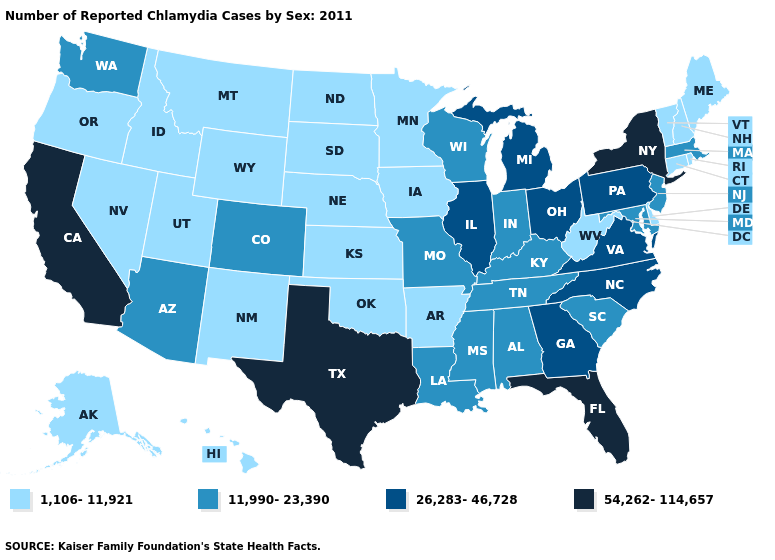Is the legend a continuous bar?
Quick response, please. No. Name the states that have a value in the range 11,990-23,390?
Write a very short answer. Alabama, Arizona, Colorado, Indiana, Kentucky, Louisiana, Maryland, Massachusetts, Mississippi, Missouri, New Jersey, South Carolina, Tennessee, Washington, Wisconsin. What is the value of Washington?
Write a very short answer. 11,990-23,390. Which states hav the highest value in the MidWest?
Give a very brief answer. Illinois, Michigan, Ohio. Name the states that have a value in the range 54,262-114,657?
Give a very brief answer. California, Florida, New York, Texas. Does Missouri have the highest value in the USA?
Short answer required. No. Name the states that have a value in the range 1,106-11,921?
Keep it brief. Alaska, Arkansas, Connecticut, Delaware, Hawaii, Idaho, Iowa, Kansas, Maine, Minnesota, Montana, Nebraska, Nevada, New Hampshire, New Mexico, North Dakota, Oklahoma, Oregon, Rhode Island, South Dakota, Utah, Vermont, West Virginia, Wyoming. Is the legend a continuous bar?
Quick response, please. No. Among the states that border Idaho , does Washington have the lowest value?
Write a very short answer. No. Which states hav the highest value in the Northeast?
Keep it brief. New York. Which states hav the highest value in the West?
Give a very brief answer. California. What is the value of South Carolina?
Answer briefly. 11,990-23,390. Does Texas have the highest value in the South?
Write a very short answer. Yes. What is the lowest value in the USA?
Answer briefly. 1,106-11,921. Name the states that have a value in the range 11,990-23,390?
Answer briefly. Alabama, Arizona, Colorado, Indiana, Kentucky, Louisiana, Maryland, Massachusetts, Mississippi, Missouri, New Jersey, South Carolina, Tennessee, Washington, Wisconsin. 